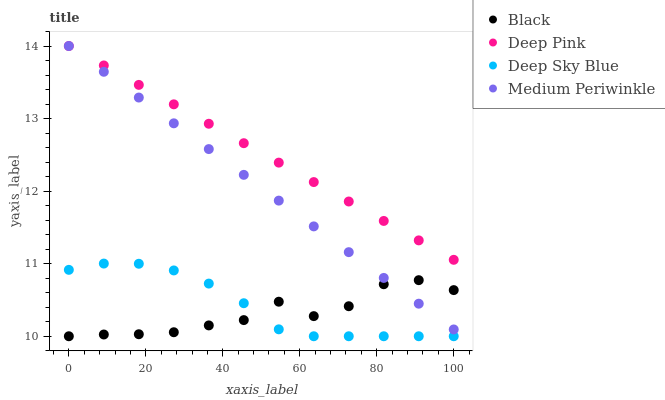Does Black have the minimum area under the curve?
Answer yes or no. Yes. Does Deep Pink have the maximum area under the curve?
Answer yes or no. Yes. Does Deep Pink have the minimum area under the curve?
Answer yes or no. No. Does Black have the maximum area under the curve?
Answer yes or no. No. Is Deep Pink the smoothest?
Answer yes or no. Yes. Is Black the roughest?
Answer yes or no. Yes. Is Black the smoothest?
Answer yes or no. No. Is Deep Pink the roughest?
Answer yes or no. No. Does Black have the lowest value?
Answer yes or no. Yes. Does Deep Pink have the lowest value?
Answer yes or no. No. Does Deep Pink have the highest value?
Answer yes or no. Yes. Does Black have the highest value?
Answer yes or no. No. Is Black less than Deep Pink?
Answer yes or no. Yes. Is Deep Pink greater than Deep Sky Blue?
Answer yes or no. Yes. Does Deep Sky Blue intersect Black?
Answer yes or no. Yes. Is Deep Sky Blue less than Black?
Answer yes or no. No. Is Deep Sky Blue greater than Black?
Answer yes or no. No. Does Black intersect Deep Pink?
Answer yes or no. No. 